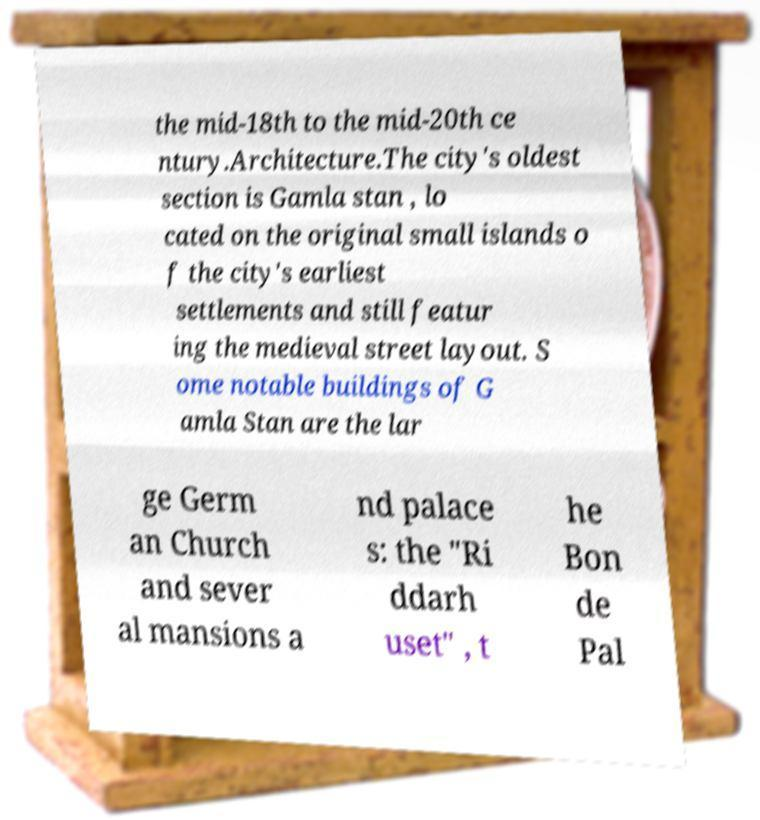Please identify and transcribe the text found in this image. the mid-18th to the mid-20th ce ntury.Architecture.The city's oldest section is Gamla stan , lo cated on the original small islands o f the city's earliest settlements and still featur ing the medieval street layout. S ome notable buildings of G amla Stan are the lar ge Germ an Church and sever al mansions a nd palace s: the "Ri ddarh uset" , t he Bon de Pal 